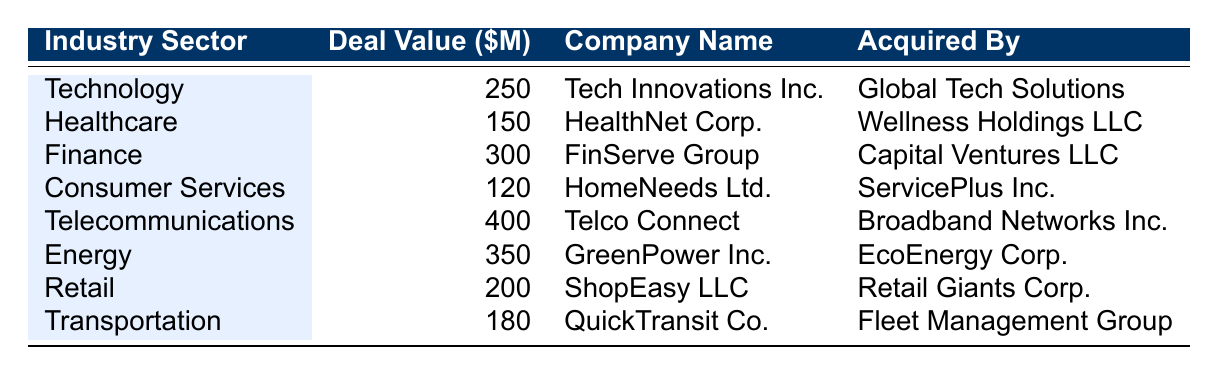What's the total deal value in the Technology sector? The deal value for Technology is listed as 250 million dollars. Therefore, the total deal value specifically for that sector is 250 million dollars.
Answer: 250 million dollars Which company was acquired in the Healthcare sector? The table indicates that HealthNet Corp. is the company acquired in the Healthcare sector.
Answer: HealthNet Corp How many companies were acquired for a deal value of 200 million dollars or more? The companies with deal values of 200 million dollars or more are: FinServe Group (300 million), GreenPower Inc. (350 million), Telecommunications (400 million), and two others. This gives a total of five companies.
Answer: 5 Is it true that more companies were acquired in the Energy sector than in Consumer Services? In the Energy sector, GreenPower Inc. was acquired with a deal value of 350 million dollars, while in Consumer Services, HomeNeeds Ltd. was acquired with a deal value of 120 million dollars. Therefore, the statement is false.
Answer: No What is the average deal value of all acquisitions listed in the table? To find the average deal value, first, sum up all deal values: 250 + 150 + 300 + 120 + 400 + 350 + 200 + 180 = 1950 million dollars. There are 8 entries, so the average is 1950/8 = 243.75 million dollars.
Answer: 243.75 million dollars Which industry sector had the highest acquisition deal value? The highest deal value listed in the table is for Telecommunications at 400 million dollars.
Answer: Telecommunications Was there any acquisition deal in the Consumer Services sector that exceeded 150 million dollars? The table shows that the deal for HomeNeeds Ltd. in the Consumer Services sector was worth 120 million dollars, which is below 150 million dollars.
Answer: No How does the deal value of the Energy sector compare to that of the Finance sector? The deal value for the Energy sector is 350 million dollars and for the Finance sector it is 300 million dollars. Therefore, the Energy sector had a higher deal value by 50 million dollars.
Answer: Energy is higher by 50 million dollars 